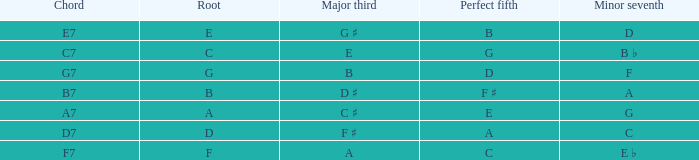What is the Major third with a Perfect fifth that is d? B. 